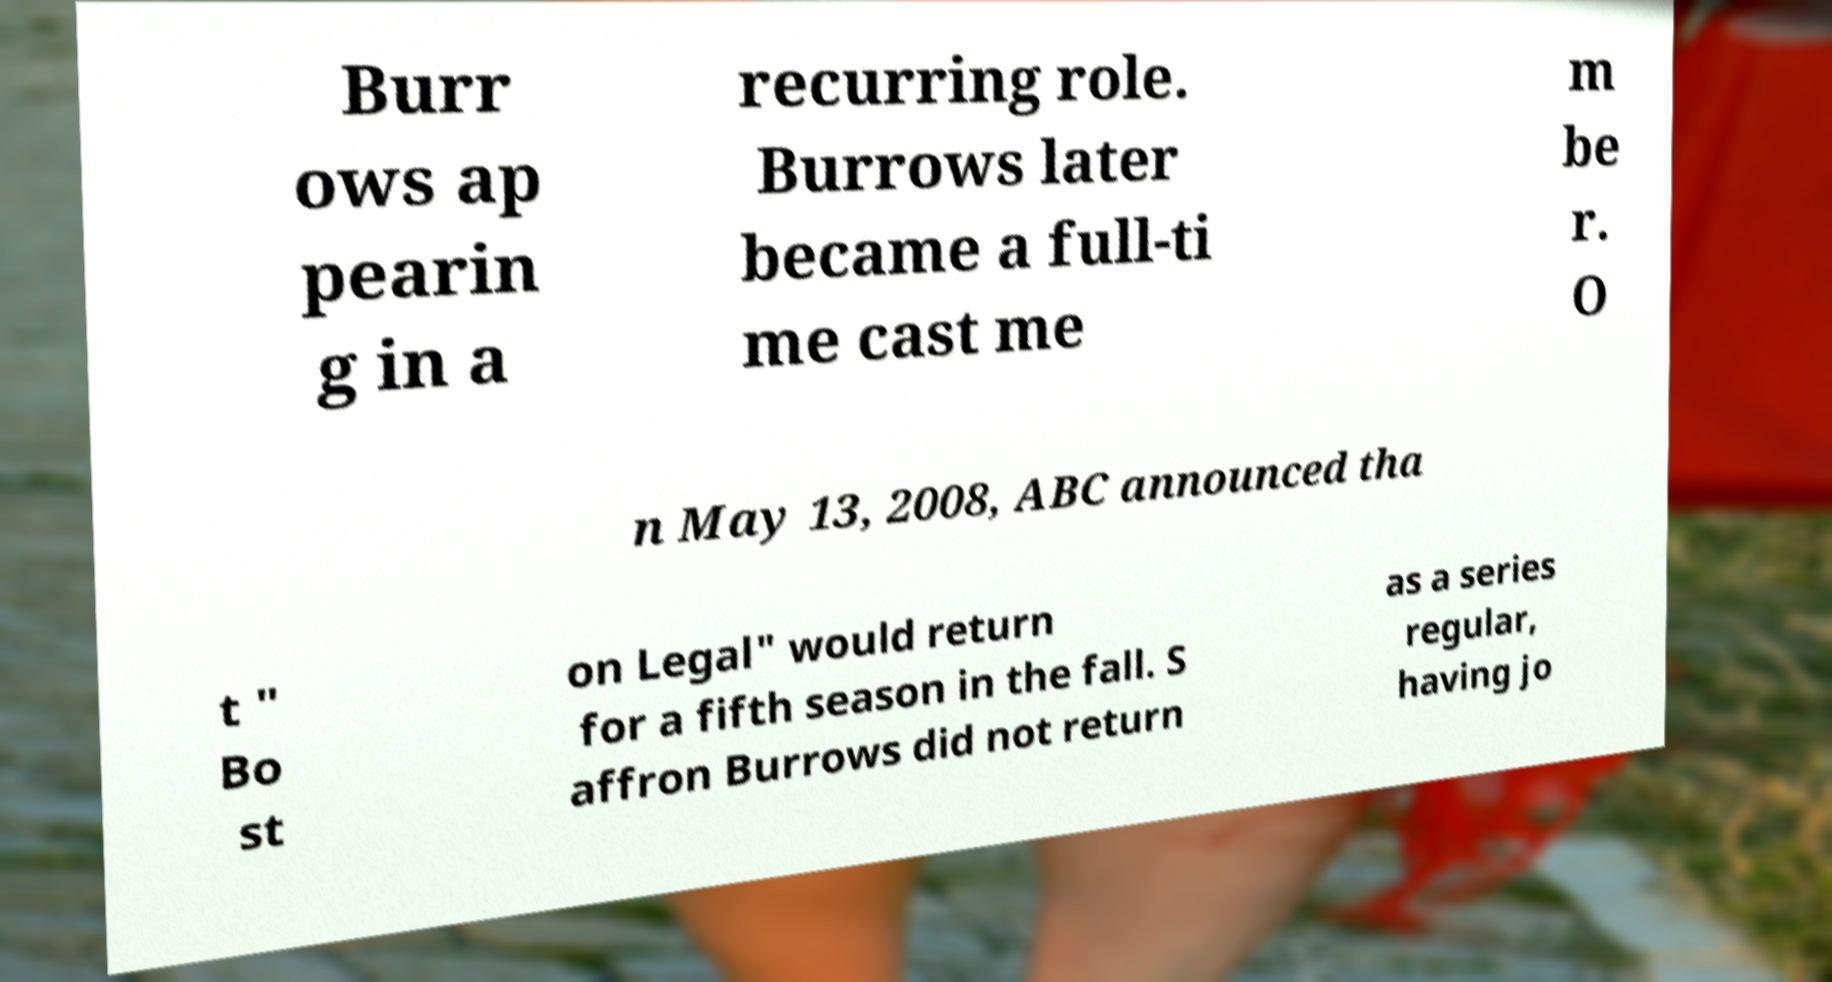There's text embedded in this image that I need extracted. Can you transcribe it verbatim? Burr ows ap pearin g in a recurring role. Burrows later became a full-ti me cast me m be r. O n May 13, 2008, ABC announced tha t " Bo st on Legal" would return for a fifth season in the fall. S affron Burrows did not return as a series regular, having jo 